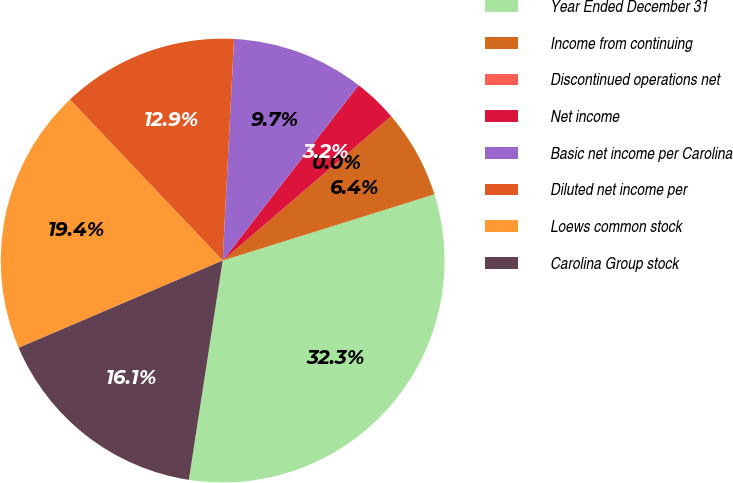Convert chart. <chart><loc_0><loc_0><loc_500><loc_500><pie_chart><fcel>Year Ended December 31<fcel>Income from continuing<fcel>Discontinued operations net<fcel>Net income<fcel>Basic net income per Carolina<fcel>Diluted net income per<fcel>Loews common stock<fcel>Carolina Group stock<nl><fcel>32.26%<fcel>6.45%<fcel>0.0%<fcel>3.23%<fcel>9.68%<fcel>12.9%<fcel>19.35%<fcel>16.13%<nl></chart> 